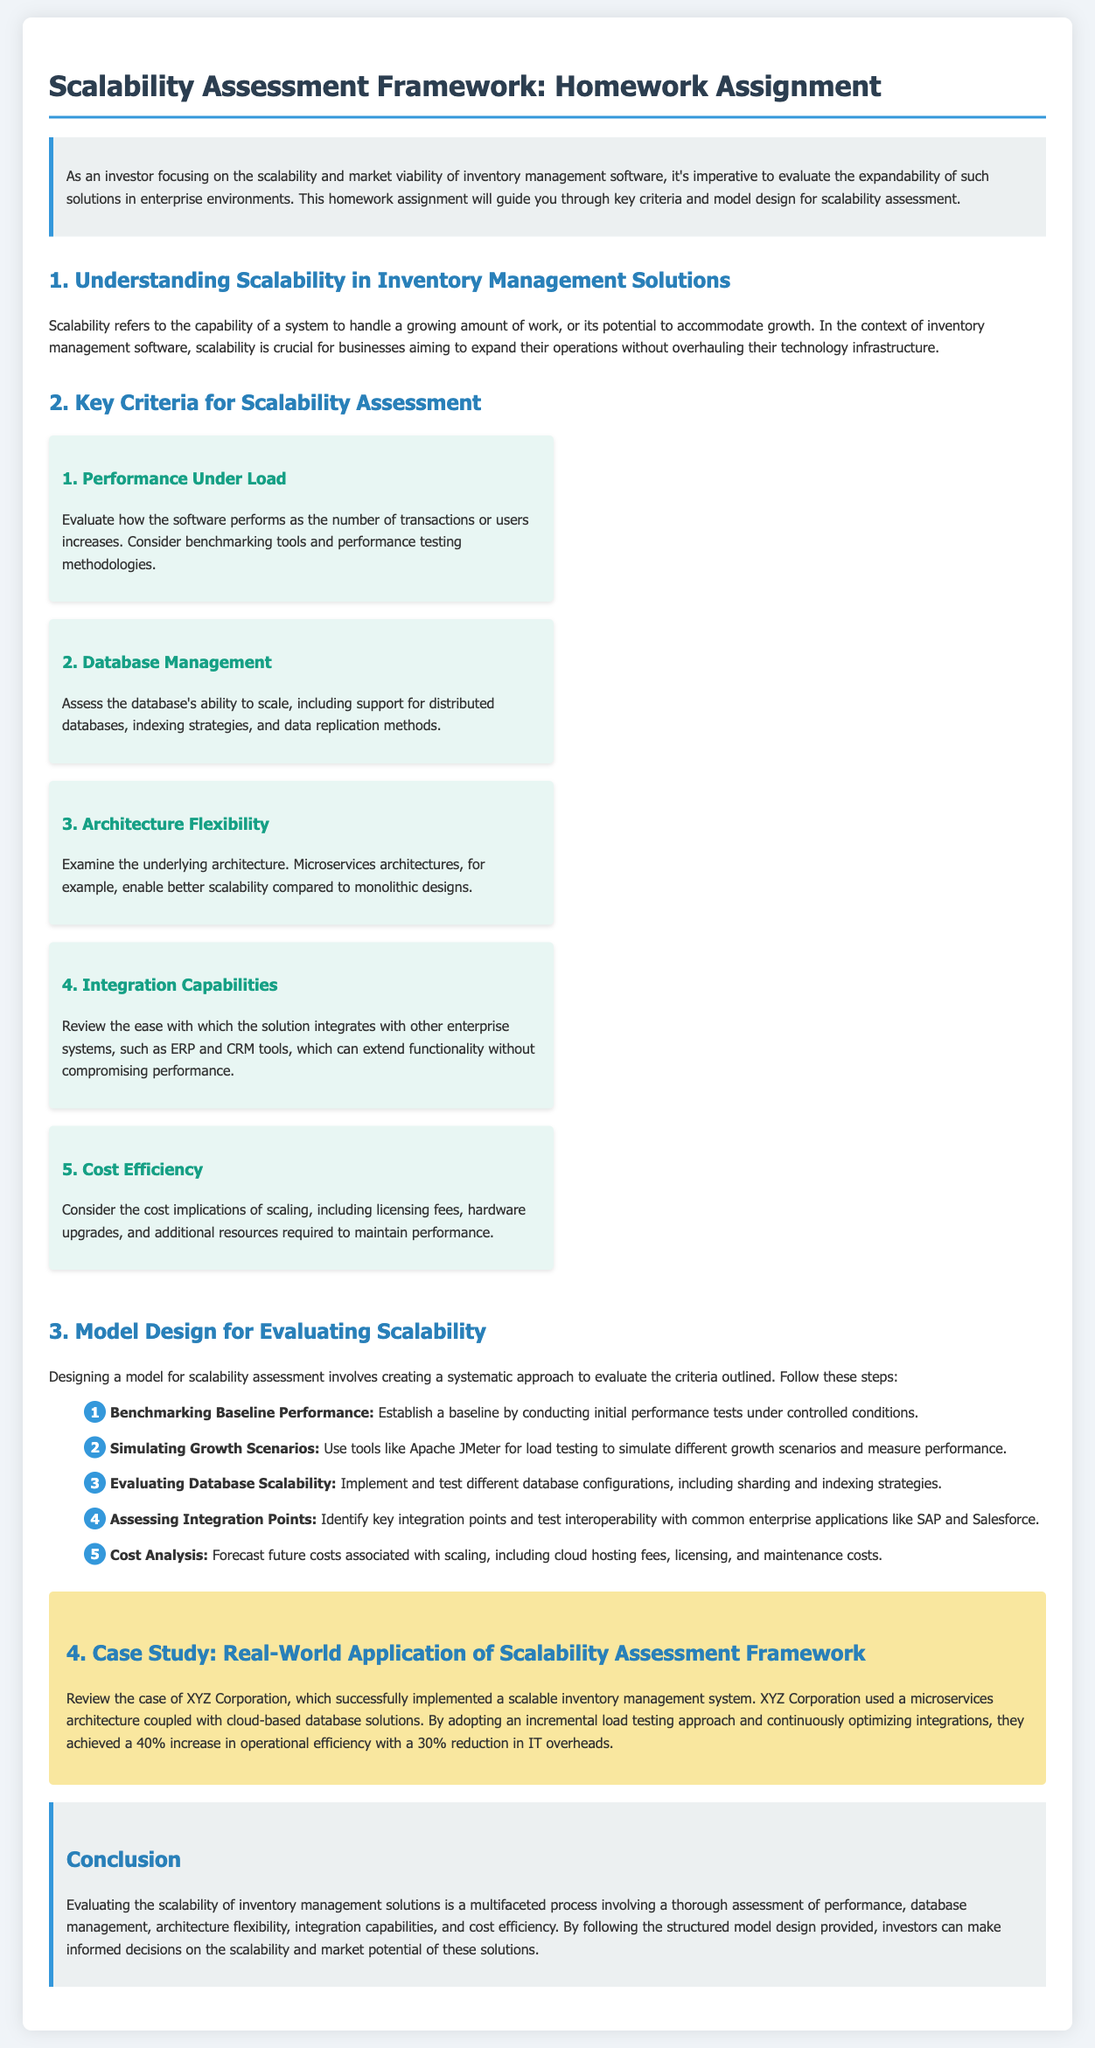What is the title of the homework assignment? The title is mentioned at the beginning of the document.
Answer: Scalability Assessment Framework: Homework Assignment What is the first criterion for scalability assessment? The first criterion is listed in a numbered format in the document.
Answer: Performance Under Load What is a key benefit of using microservices architecture in scalability? The document explains the advantages of certain architectures in the context of scalability.
Answer: Better scalability How many steps are included in the model design for evaluating scalability? The list of steps is numbered in the document.
Answer: Five What was the percentage increase in operational efficiency achieved by XYZ Corporation? The case study section provides this specific information.
Answer: 40% Which tool is mentioned for load testing in the scalability model design? The document lists specific tools applicable for testing purposes.
Answer: Apache JMeter What type of companies should consider the integration capabilities criterion? The integration capabilities criterion is relevant for specific types of systems.
Answer: Enterprise systems What is the main focus of the homework assignment? The introductory paragraph specifies the homework's purpose.
Answer: Evaluating the expandability of inventory management solutions 